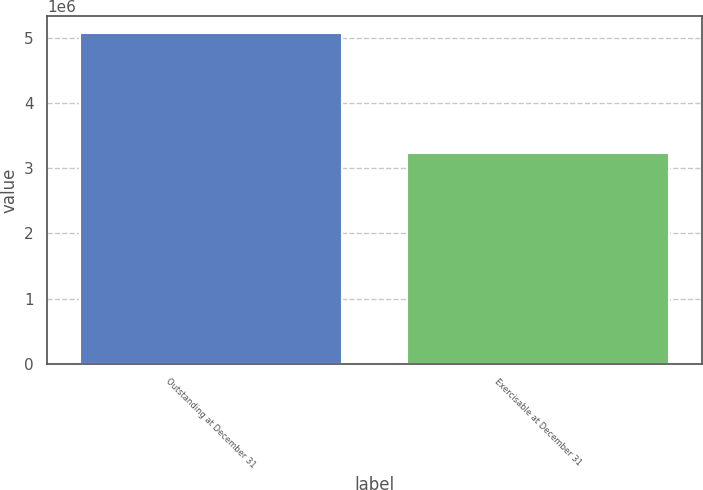Convert chart. <chart><loc_0><loc_0><loc_500><loc_500><bar_chart><fcel>Outstanding at December 31<fcel>Exercisable at December 31<nl><fcel>5.0794e+06<fcel>3.23738e+06<nl></chart> 